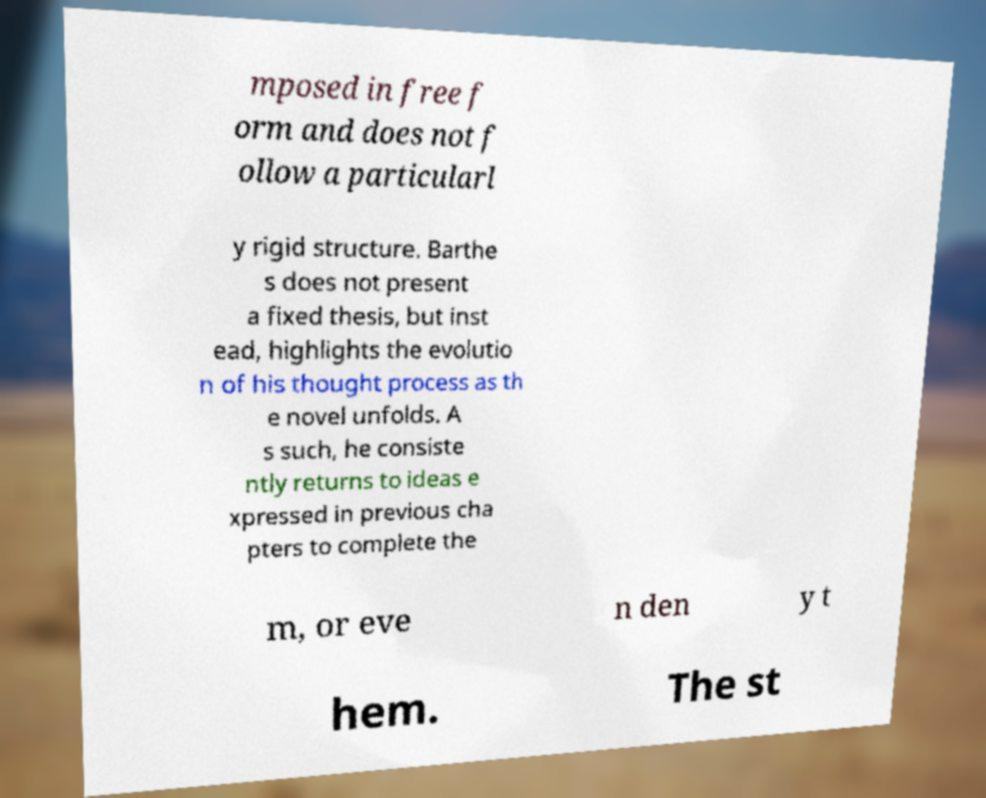I need the written content from this picture converted into text. Can you do that? mposed in free f orm and does not f ollow a particularl y rigid structure. Barthe s does not present a fixed thesis, but inst ead, highlights the evolutio n of his thought process as th e novel unfolds. A s such, he consiste ntly returns to ideas e xpressed in previous cha pters to complete the m, or eve n den y t hem. The st 